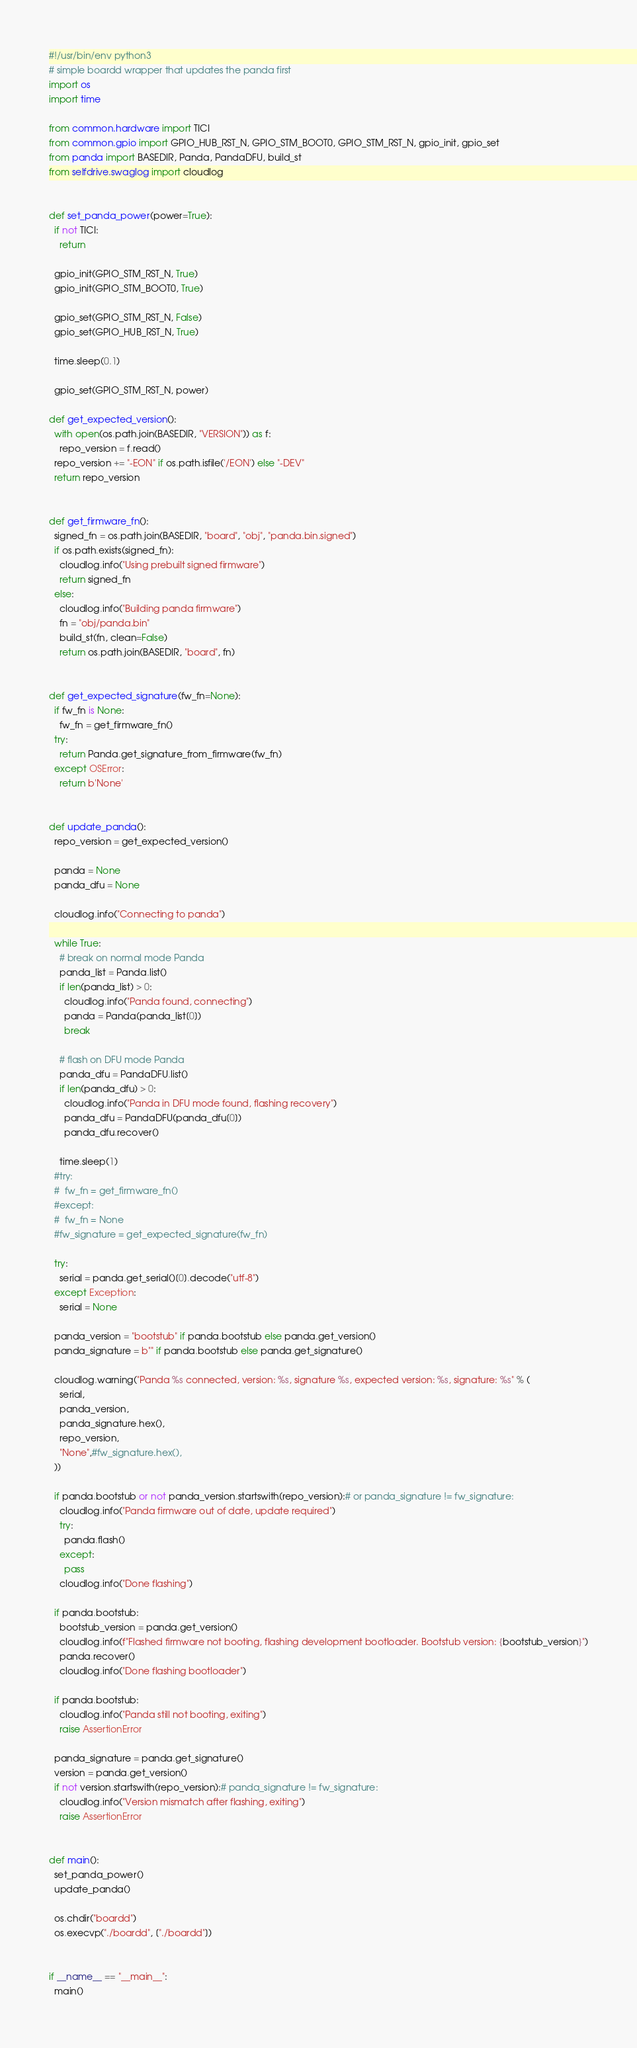<code> <loc_0><loc_0><loc_500><loc_500><_Python_>#!/usr/bin/env python3
# simple boardd wrapper that updates the panda first
import os
import time

from common.hardware import TICI
from common.gpio import GPIO_HUB_RST_N, GPIO_STM_BOOT0, GPIO_STM_RST_N, gpio_init, gpio_set
from panda import BASEDIR, Panda, PandaDFU, build_st
from selfdrive.swaglog import cloudlog


def set_panda_power(power=True):
  if not TICI:
    return

  gpio_init(GPIO_STM_RST_N, True)
  gpio_init(GPIO_STM_BOOT0, True)

  gpio_set(GPIO_STM_RST_N, False)
  gpio_set(GPIO_HUB_RST_N, True)

  time.sleep(0.1)

  gpio_set(GPIO_STM_RST_N, power)

def get_expected_version():
  with open(os.path.join(BASEDIR, "VERSION")) as f:
    repo_version = f.read()
  repo_version += "-EON" if os.path.isfile('/EON') else "-DEV"
  return repo_version


def get_firmware_fn():
  signed_fn = os.path.join(BASEDIR, "board", "obj", "panda.bin.signed")
  if os.path.exists(signed_fn):
    cloudlog.info("Using prebuilt signed firmware")
    return signed_fn
  else:
    cloudlog.info("Building panda firmware")
    fn = "obj/panda.bin"
    build_st(fn, clean=False)
    return os.path.join(BASEDIR, "board", fn)


def get_expected_signature(fw_fn=None):
  if fw_fn is None:
    fw_fn = get_firmware_fn()
  try:
    return Panda.get_signature_from_firmware(fw_fn)
  except OSError:
    return b'None'


def update_panda():
  repo_version = get_expected_version()
  
  panda = None
  panda_dfu = None

  cloudlog.info("Connecting to panda")

  while True:
    # break on normal mode Panda
    panda_list = Panda.list()
    if len(panda_list) > 0:
      cloudlog.info("Panda found, connecting")
      panda = Panda(panda_list[0])
      break

    # flash on DFU mode Panda
    panda_dfu = PandaDFU.list()
    if len(panda_dfu) > 0:
      cloudlog.info("Panda in DFU mode found, flashing recovery")
      panda_dfu = PandaDFU(panda_dfu[0])
      panda_dfu.recover()

    time.sleep(1)
  #try:
  #  fw_fn = get_firmware_fn()
  #except:
  #  fw_fn = None
  #fw_signature = get_expected_signature(fw_fn)

  try:
    serial = panda.get_serial()[0].decode("utf-8")
  except Exception:
    serial = None

  panda_version = "bootstub" if panda.bootstub else panda.get_version()
  panda_signature = b"" if panda.bootstub else panda.get_signature()

  cloudlog.warning("Panda %s connected, version: %s, signature %s, expected version: %s, signature: %s" % (
    serial,
    panda_version,
    panda_signature.hex(),
    repo_version,
    "None",#fw_signature.hex(),
  ))

  if panda.bootstub or not panda_version.startswith(repo_version):# or panda_signature != fw_signature:
    cloudlog.info("Panda firmware out of date, update required")
    try:
      panda.flash()
    except:
      pass
    cloudlog.info("Done flashing")

  if panda.bootstub:
    bootstub_version = panda.get_version()
    cloudlog.info(f"Flashed firmware not booting, flashing development bootloader. Bootstub version: {bootstub_version}")
    panda.recover()
    cloudlog.info("Done flashing bootloader")

  if panda.bootstub:
    cloudlog.info("Panda still not booting, exiting")
    raise AssertionError

  panda_signature = panda.get_signature()
  version = panda.get_version()
  if not version.startswith(repo_version):# panda_signature != fw_signature:
    cloudlog.info("Version mismatch after flashing, exiting")
    raise AssertionError


def main():
  set_panda_power()
  update_panda()

  os.chdir("boardd")
  os.execvp("./boardd", ["./boardd"])


if __name__ == "__main__":
  main()
</code> 